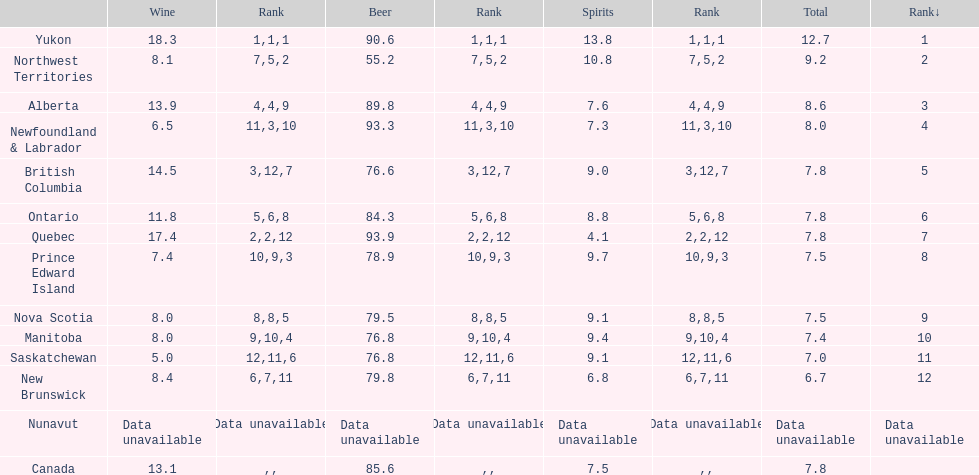In which province is the amount of spirits consumed the least? Quebec. 